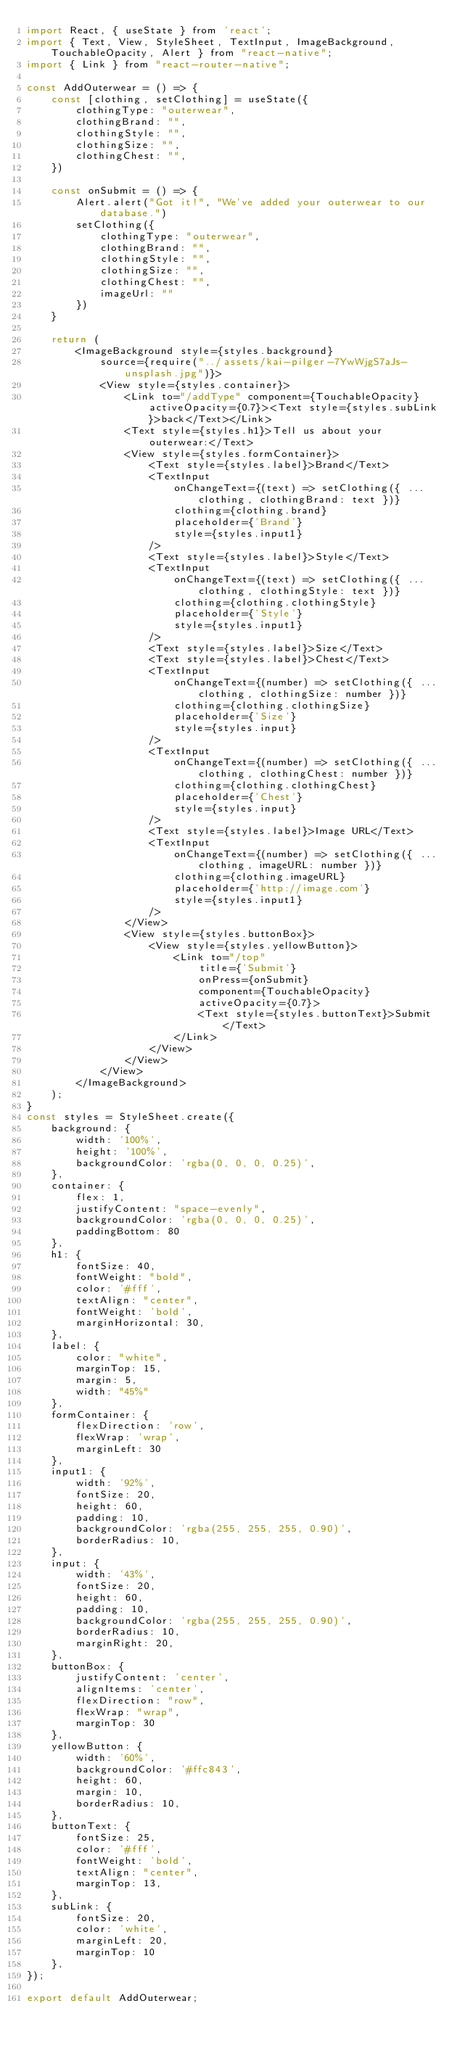<code> <loc_0><loc_0><loc_500><loc_500><_JavaScript_>import React, { useState } from 'react';
import { Text, View, StyleSheet, TextInput, ImageBackground, TouchableOpacity, Alert } from "react-native";
import { Link } from "react-router-native";

const AddOuterwear = () => {
    const [clothing, setClothing] = useState({
        clothingType: "outerwear",
        clothingBrand: "",
        clothingStyle: "",
        clothingSize: "",
        clothingChest: "",
    })

    const onSubmit = () => {
        Alert.alert("Got it!", "We've added your outerwear to our database.")
        setClothing({
            clothingType: "outerwear",
            clothingBrand: "",
            clothingStyle: "",
            clothingSize: "",
            clothingChest: "",
            imageUrl: ""
        })
    }

    return (
        <ImageBackground style={styles.background}
            source={require("../assets/kai-pilger-7YwWjgS7aJs-unsplash.jpg")}>
            <View style={styles.container}>
                <Link to="/addType" component={TouchableOpacity} activeOpacity={0.7}><Text style={styles.subLink}>back</Text></Link>
                <Text style={styles.h1}>Tell us about your outerwear:</Text>
                <View style={styles.formContainer}>
                    <Text style={styles.label}>Brand</Text>
                    <TextInput
                        onChangeText={(text) => setClothing({ ...clothing, clothingBrand: text })}
                        clothing={clothing.brand}
                        placeholder={'Brand'}
                        style={styles.input1}
                    />
                    <Text style={styles.label}>Style</Text>
                    <TextInput
                        onChangeText={(text) => setClothing({ ...clothing, clothingStyle: text })}
                        clothing={clothing.clothingStyle}
                        placeholder={'Style'}
                        style={styles.input1}
                    />
                    <Text style={styles.label}>Size</Text>
                    <Text style={styles.label}>Chest</Text>
                    <TextInput
                        onChangeText={(number) => setClothing({ ...clothing, clothingSize: number })}
                        clothing={clothing.clothingSize}
                        placeholder={'Size'}
                        style={styles.input}
                    />
                    <TextInput
                        onChangeText={(number) => setClothing({ ...clothing, clothingChest: number })}
                        clothing={clothing.clothingChest}
                        placeholder={'Chest'}
                        style={styles.input}
                    />
                    <Text style={styles.label}>Image URL</Text>
                    <TextInput
                        onChangeText={(number) => setClothing({ ...clothing, imageURL: number })}
                        clothing={clothing.imageURL}
                        placeholder={'http://image.com'}
                        style={styles.input1}
                    />
                </View>
                <View style={styles.buttonBox}>
                    <View style={styles.yellowButton}>
                        <Link to="/top"
                            title={'Submit'}
                            onPress={onSubmit}
                            component={TouchableOpacity}
                            activeOpacity={0.7}>
                            <Text style={styles.buttonText}>Submit</Text>
                        </Link>
                    </View>
                </View>
            </View>
        </ImageBackground>
    );
}
const styles = StyleSheet.create({
    background: {
        width: '100%',
        height: '100%',
        backgroundColor: 'rgba(0, 0, 0, 0.25)',
    },
    container: {
        flex: 1,
        justifyContent: "space-evenly",
        backgroundColor: 'rgba(0, 0, 0, 0.25)',
        paddingBottom: 80
    },
    h1: {
        fontSize: 40,
        fontWeight: "bold",
        color: '#fff',
        textAlign: "center",
        fontWeight: 'bold',
        marginHorizontal: 30,
    },
    label: {
        color: "white",
        marginTop: 15,
        margin: 5,
        width: "45%"
    },
    formContainer: {
        flexDirection: 'row',
        flexWrap: 'wrap',
        marginLeft: 30
    },
    input1: {
        width: '92%',
        fontSize: 20,
        height: 60,
        padding: 10,
        backgroundColor: 'rgba(255, 255, 255, 0.90)',
        borderRadius: 10,
    },
    input: {
        width: '43%',
        fontSize: 20,
        height: 60,
        padding: 10,
        backgroundColor: 'rgba(255, 255, 255, 0.90)',
        borderRadius: 10,
        marginRight: 20,
    },
    buttonBox: {
        justifyContent: 'center',
        alignItems: 'center',
        flexDirection: "row",
        flexWrap: "wrap",
        marginTop: 30
    },
    yellowButton: {
        width: '60%',
        backgroundColor: '#ffc843',
        height: 60,
        margin: 10,
        borderRadius: 10,
    },
    buttonText: {
        fontSize: 25,
        color: '#fff',
        fontWeight: 'bold',
        textAlign: "center",
        marginTop: 13,
    },
    subLink: {
        fontSize: 20,
        color: 'white',
        marginLeft: 20,
        marginTop: 10
    },
});

export default AddOuterwear;</code> 